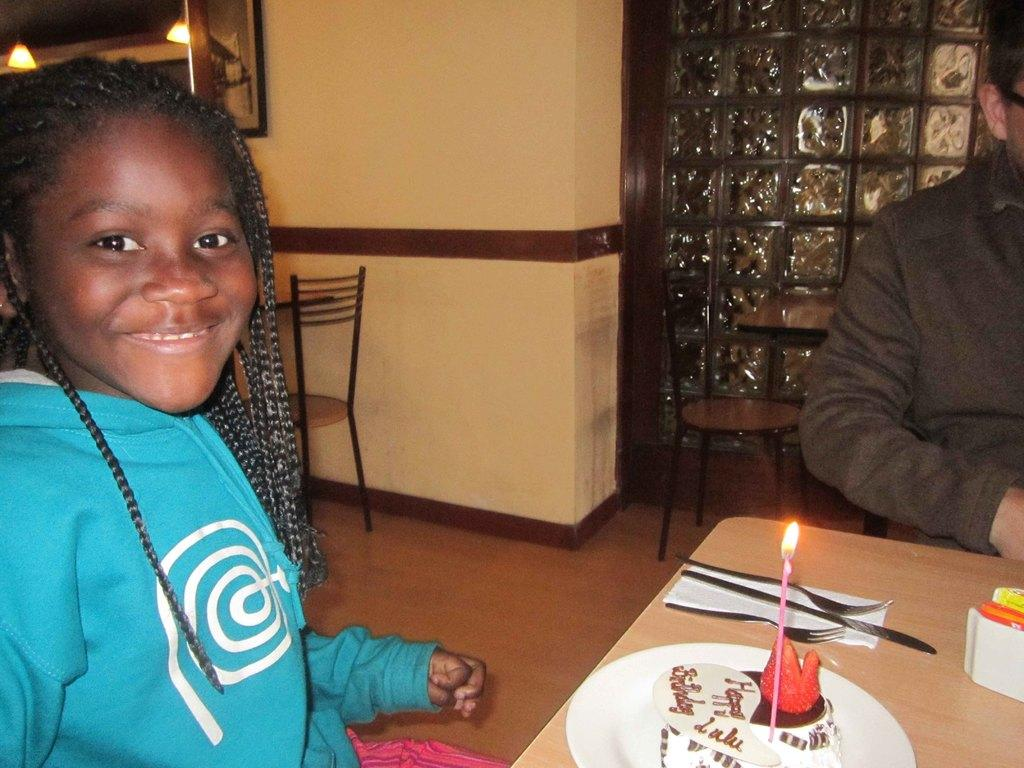Who is the main subject in the image? There is a girl in the image. What is the girl doing in the image? The girl is sitting at a table. What is on the table with the girl? There is a cake on the table. What type of collar is the girl wearing in the image? There is no collar visible in the image, as the girl is not wearing any clothing that would have a collar. 